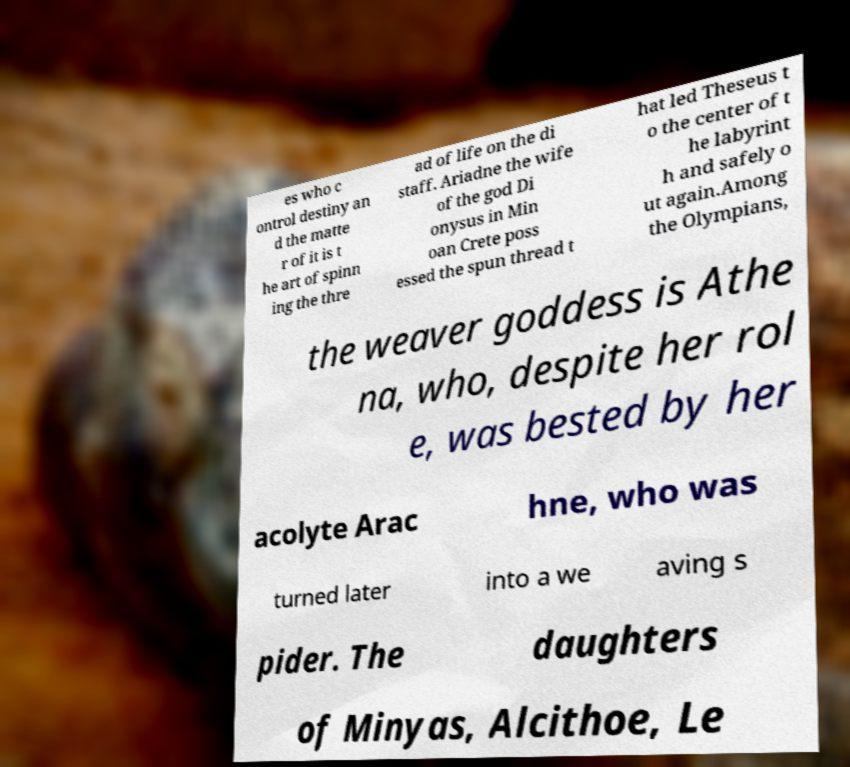I need the written content from this picture converted into text. Can you do that? es who c ontrol destiny an d the matte r of it is t he art of spinn ing the thre ad of life on the di staff. Ariadne the wife of the god Di onysus in Min oan Crete poss essed the spun thread t hat led Theseus t o the center of t he labyrint h and safely o ut again.Among the Olympians, the weaver goddess is Athe na, who, despite her rol e, was bested by her acolyte Arac hne, who was turned later into a we aving s pider. The daughters of Minyas, Alcithoe, Le 